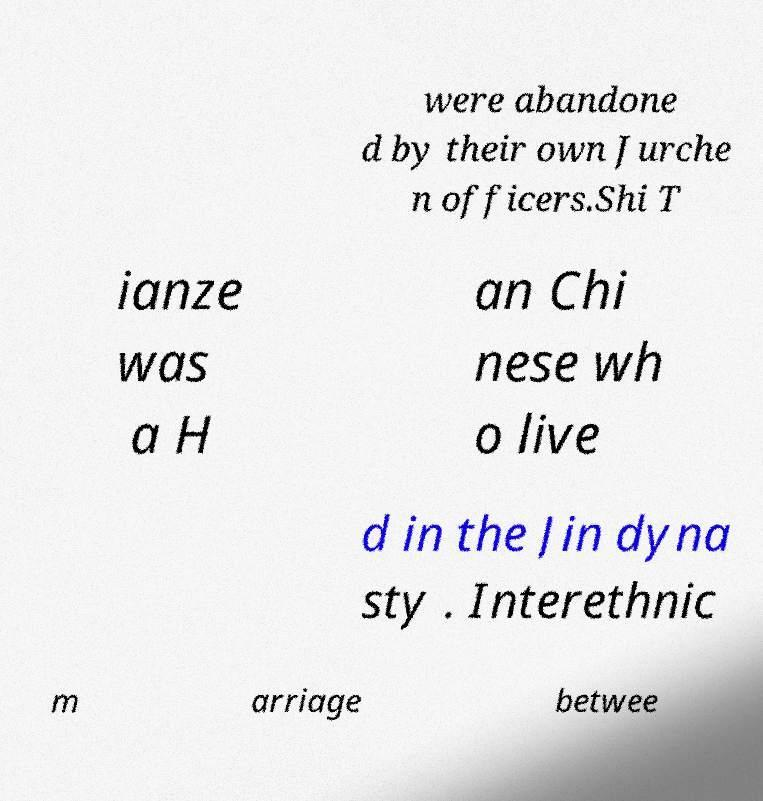Could you assist in decoding the text presented in this image and type it out clearly? were abandone d by their own Jurche n officers.Shi T ianze was a H an Chi nese wh o live d in the Jin dyna sty . Interethnic m arriage betwee 